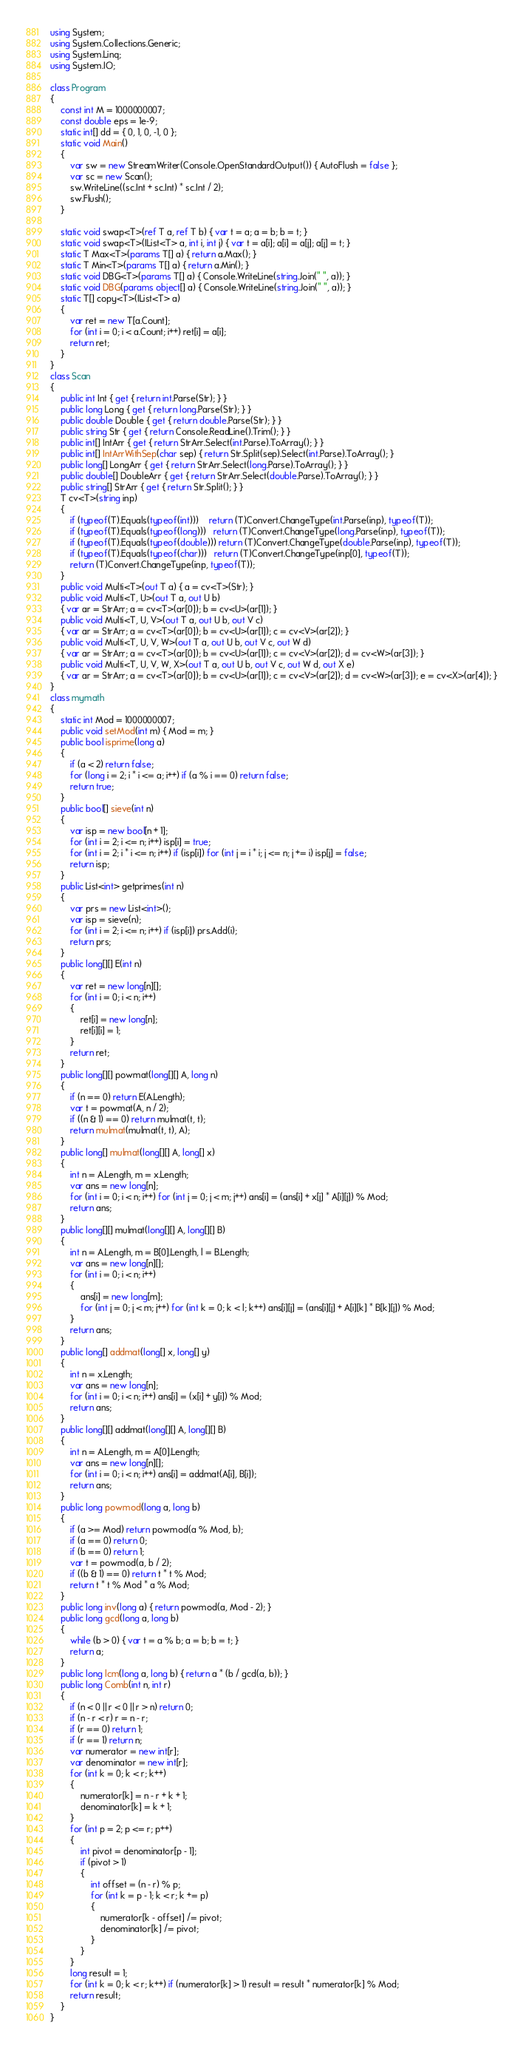<code> <loc_0><loc_0><loc_500><loc_500><_C#_>using System;
using System.Collections.Generic;
using System.Linq;
using System.IO;

class Program
{
    const int M = 1000000007;
    const double eps = 1e-9;
    static int[] dd = { 0, 1, 0, -1, 0 };
    static void Main()
    {
        var sw = new StreamWriter(Console.OpenStandardOutput()) { AutoFlush = false };
        var sc = new Scan();
        sw.WriteLine((sc.Int + sc.Int) * sc.Int / 2);
        sw.Flush();
    }

    static void swap<T>(ref T a, ref T b) { var t = a; a = b; b = t; }
    static void swap<T>(IList<T> a, int i, int j) { var t = a[i]; a[i] = a[j]; a[j] = t; }
    static T Max<T>(params T[] a) { return a.Max(); }
    static T Min<T>(params T[] a) { return a.Min(); }
    static void DBG<T>(params T[] a) { Console.WriteLine(string.Join(" ", a)); }
    static void DBG(params object[] a) { Console.WriteLine(string.Join(" ", a)); }
    static T[] copy<T>(IList<T> a)
    {
        var ret = new T[a.Count];
        for (int i = 0; i < a.Count; i++) ret[i] = a[i];
        return ret;
    }
}
class Scan
{
    public int Int { get { return int.Parse(Str); } }
    public long Long { get { return long.Parse(Str); } }
    public double Double { get { return double.Parse(Str); } }
    public string Str { get { return Console.ReadLine().Trim(); } }
    public int[] IntArr { get { return StrArr.Select(int.Parse).ToArray(); } }
    public int[] IntArrWithSep(char sep) { return Str.Split(sep).Select(int.Parse).ToArray(); }
    public long[] LongArr { get { return StrArr.Select(long.Parse).ToArray(); } }
    public double[] DoubleArr { get { return StrArr.Select(double.Parse).ToArray(); } }
    public string[] StrArr { get { return Str.Split(); } }
    T cv<T>(string inp)
    {
        if (typeof(T).Equals(typeof(int)))    return (T)Convert.ChangeType(int.Parse(inp), typeof(T));
        if (typeof(T).Equals(typeof(long)))   return (T)Convert.ChangeType(long.Parse(inp), typeof(T));
        if (typeof(T).Equals(typeof(double))) return (T)Convert.ChangeType(double.Parse(inp), typeof(T));
        if (typeof(T).Equals(typeof(char)))   return (T)Convert.ChangeType(inp[0], typeof(T));
        return (T)Convert.ChangeType(inp, typeof(T));
    }
    public void Multi<T>(out T a) { a = cv<T>(Str); }
    public void Multi<T, U>(out T a, out U b)
    { var ar = StrArr; a = cv<T>(ar[0]); b = cv<U>(ar[1]); }
    public void Multi<T, U, V>(out T a, out U b, out V c)
    { var ar = StrArr; a = cv<T>(ar[0]); b = cv<U>(ar[1]); c = cv<V>(ar[2]); }
    public void Multi<T, U, V, W>(out T a, out U b, out V c, out W d)
    { var ar = StrArr; a = cv<T>(ar[0]); b = cv<U>(ar[1]); c = cv<V>(ar[2]); d = cv<W>(ar[3]); }
    public void Multi<T, U, V, W, X>(out T a, out U b, out V c, out W d, out X e)
    { var ar = StrArr; a = cv<T>(ar[0]); b = cv<U>(ar[1]); c = cv<V>(ar[2]); d = cv<W>(ar[3]); e = cv<X>(ar[4]); }
}
class mymath
{
    static int Mod = 1000000007;
    public void setMod(int m) { Mod = m; }
    public bool isprime(long a)
    {
        if (a < 2) return false;
        for (long i = 2; i * i <= a; i++) if (a % i == 0) return false;
        return true;
    }
    public bool[] sieve(int n)
    {
        var isp = new bool[n + 1];
        for (int i = 2; i <= n; i++) isp[i] = true;
        for (int i = 2; i * i <= n; i++) if (isp[i]) for (int j = i * i; j <= n; j += i) isp[j] = false;
        return isp;
    }
    public List<int> getprimes(int n)
    {
        var prs = new List<int>();
        var isp = sieve(n);
        for (int i = 2; i <= n; i++) if (isp[i]) prs.Add(i);
        return prs;
    }
    public long[][] E(int n)
    {
        var ret = new long[n][];
        for (int i = 0; i < n; i++)
        {
            ret[i] = new long[n];
            ret[i][i] = 1;
        }
        return ret;
    }
    public long[][] powmat(long[][] A, long n)
    {
        if (n == 0) return E(A.Length);
        var t = powmat(A, n / 2);
        if ((n & 1) == 0) return mulmat(t, t);
        return mulmat(mulmat(t, t), A);
    }
    public long[] mulmat(long[][] A, long[] x)
    {
        int n = A.Length, m = x.Length;
        var ans = new long[n];
        for (int i = 0; i < n; i++) for (int j = 0; j < m; j++) ans[i] = (ans[i] + x[j] * A[i][j]) % Mod;
        return ans;
    }
    public long[][] mulmat(long[][] A, long[][] B)
    {
        int n = A.Length, m = B[0].Length, l = B.Length;
        var ans = new long[n][];
        for (int i = 0; i < n; i++)
        {
            ans[i] = new long[m];
            for (int j = 0; j < m; j++) for (int k = 0; k < l; k++) ans[i][j] = (ans[i][j] + A[i][k] * B[k][j]) % Mod;
        }
        return ans;
    }
    public long[] addmat(long[] x, long[] y)
    {
        int n = x.Length;
        var ans = new long[n];
        for (int i = 0; i < n; i++) ans[i] = (x[i] + y[i]) % Mod;
        return ans;
    }
    public long[][] addmat(long[][] A, long[][] B)
    {
        int n = A.Length, m = A[0].Length;
        var ans = new long[n][];
        for (int i = 0; i < n; i++) ans[i] = addmat(A[i], B[i]);
        return ans;
    }
    public long powmod(long a, long b)
    {
        if (a >= Mod) return powmod(a % Mod, b);
        if (a == 0) return 0;
        if (b == 0) return 1;
        var t = powmod(a, b / 2);
        if ((b & 1) == 0) return t * t % Mod;
        return t * t % Mod * a % Mod;
    }
    public long inv(long a) { return powmod(a, Mod - 2); }
    public long gcd(long a, long b)
    {
        while (b > 0) { var t = a % b; a = b; b = t; }
        return a;
    }
    public long lcm(long a, long b) { return a * (b / gcd(a, b)); }
    public long Comb(int n, int r)
    {
        if (n < 0 || r < 0 || r > n) return 0;
        if (n - r < r) r = n - r;
        if (r == 0) return 1;
        if (r == 1) return n;
        var numerator = new int[r];
        var denominator = new int[r];
        for (int k = 0; k < r; k++)
        {
            numerator[k] = n - r + k + 1;
            denominator[k] = k + 1;
        }
        for (int p = 2; p <= r; p++)
        {
            int pivot = denominator[p - 1];
            if (pivot > 1)
            {
                int offset = (n - r) % p;
                for (int k = p - 1; k < r; k += p)
                {
                    numerator[k - offset] /= pivot;
                    denominator[k] /= pivot;
                }
            }
        }
        long result = 1;
        for (int k = 0; k < r; k++) if (numerator[k] > 1) result = result * numerator[k] % Mod;
        return result;
    }
}
</code> 